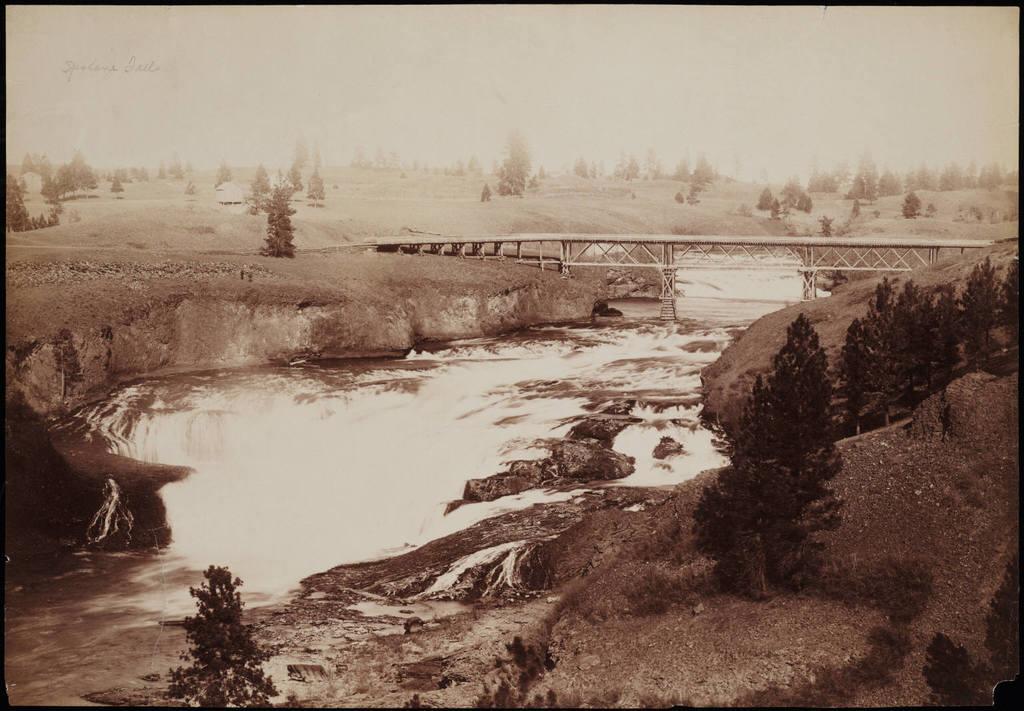Can you describe this image briefly? In this image at the bottom, there are stones, plants, waves and water. In the middle there is a bridge. In the background there are trees, text, land and sky. 